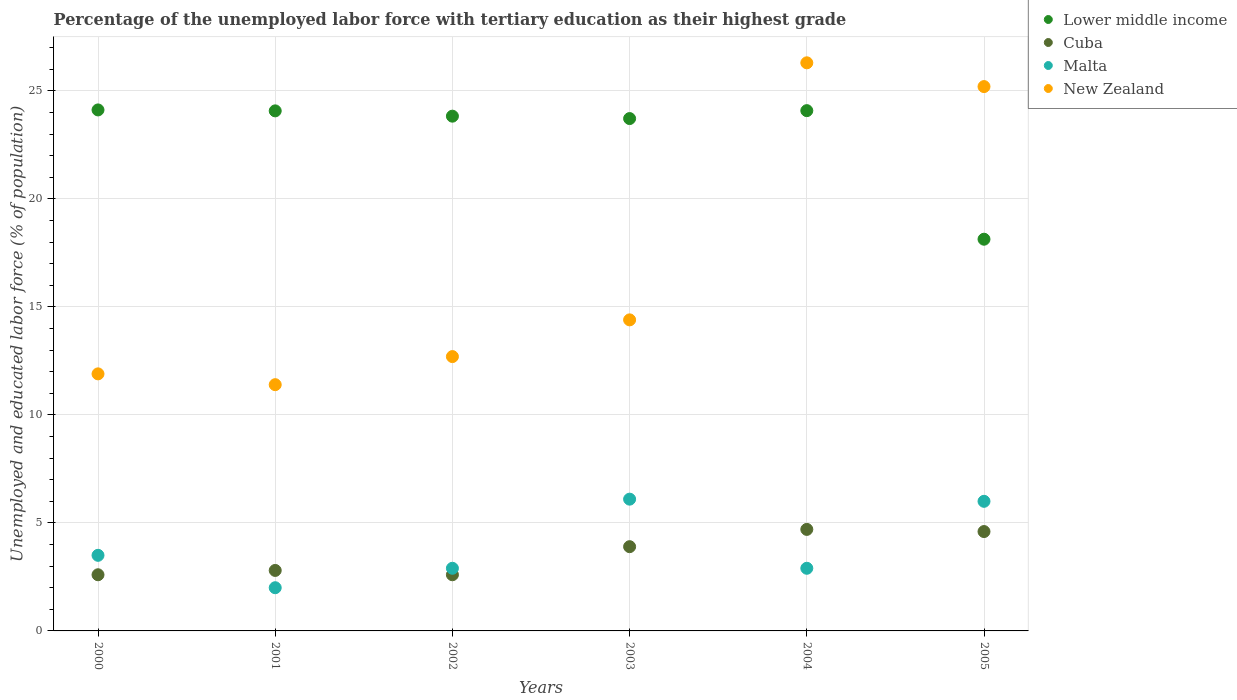What is the percentage of the unemployed labor force with tertiary education in Cuba in 2000?
Your answer should be very brief. 2.6. Across all years, what is the maximum percentage of the unemployed labor force with tertiary education in New Zealand?
Provide a short and direct response. 26.3. Across all years, what is the minimum percentage of the unemployed labor force with tertiary education in Cuba?
Your response must be concise. 2.6. In which year was the percentage of the unemployed labor force with tertiary education in Malta maximum?
Offer a very short reply. 2003. What is the total percentage of the unemployed labor force with tertiary education in Lower middle income in the graph?
Your answer should be compact. 137.96. What is the difference between the percentage of the unemployed labor force with tertiary education in Malta in 2003 and that in 2005?
Your answer should be very brief. 0.1. What is the difference between the percentage of the unemployed labor force with tertiary education in Cuba in 2003 and the percentage of the unemployed labor force with tertiary education in Malta in 2005?
Give a very brief answer. -2.1. What is the average percentage of the unemployed labor force with tertiary education in Malta per year?
Provide a short and direct response. 3.9. In the year 2002, what is the difference between the percentage of the unemployed labor force with tertiary education in Lower middle income and percentage of the unemployed labor force with tertiary education in Malta?
Offer a terse response. 20.93. In how many years, is the percentage of the unemployed labor force with tertiary education in Cuba greater than 24 %?
Offer a terse response. 0. What is the ratio of the percentage of the unemployed labor force with tertiary education in Lower middle income in 2001 to that in 2004?
Your response must be concise. 1. Is the percentage of the unemployed labor force with tertiary education in New Zealand in 2002 less than that in 2005?
Provide a succinct answer. Yes. Is the difference between the percentage of the unemployed labor force with tertiary education in Lower middle income in 2000 and 2005 greater than the difference between the percentage of the unemployed labor force with tertiary education in Malta in 2000 and 2005?
Offer a terse response. Yes. What is the difference between the highest and the second highest percentage of the unemployed labor force with tertiary education in New Zealand?
Make the answer very short. 1.1. What is the difference between the highest and the lowest percentage of the unemployed labor force with tertiary education in New Zealand?
Your response must be concise. 14.9. In how many years, is the percentage of the unemployed labor force with tertiary education in Malta greater than the average percentage of the unemployed labor force with tertiary education in Malta taken over all years?
Your answer should be compact. 2. Is the sum of the percentage of the unemployed labor force with tertiary education in Lower middle income in 2001 and 2005 greater than the maximum percentage of the unemployed labor force with tertiary education in Cuba across all years?
Make the answer very short. Yes. How many years are there in the graph?
Your answer should be very brief. 6. What is the difference between two consecutive major ticks on the Y-axis?
Offer a very short reply. 5. Where does the legend appear in the graph?
Make the answer very short. Top right. How many legend labels are there?
Provide a succinct answer. 4. How are the legend labels stacked?
Make the answer very short. Vertical. What is the title of the graph?
Your answer should be compact. Percentage of the unemployed labor force with tertiary education as their highest grade. What is the label or title of the Y-axis?
Provide a succinct answer. Unemployed and educated labor force (% of population). What is the Unemployed and educated labor force (% of population) of Lower middle income in 2000?
Offer a terse response. 24.12. What is the Unemployed and educated labor force (% of population) in Cuba in 2000?
Your answer should be compact. 2.6. What is the Unemployed and educated labor force (% of population) in New Zealand in 2000?
Offer a terse response. 11.9. What is the Unemployed and educated labor force (% of population) in Lower middle income in 2001?
Offer a very short reply. 24.08. What is the Unemployed and educated labor force (% of population) in Cuba in 2001?
Your answer should be very brief. 2.8. What is the Unemployed and educated labor force (% of population) of Malta in 2001?
Make the answer very short. 2. What is the Unemployed and educated labor force (% of population) of New Zealand in 2001?
Your response must be concise. 11.4. What is the Unemployed and educated labor force (% of population) in Lower middle income in 2002?
Ensure brevity in your answer.  23.83. What is the Unemployed and educated labor force (% of population) in Cuba in 2002?
Provide a succinct answer. 2.6. What is the Unemployed and educated labor force (% of population) in Malta in 2002?
Your answer should be compact. 2.9. What is the Unemployed and educated labor force (% of population) in New Zealand in 2002?
Offer a very short reply. 12.7. What is the Unemployed and educated labor force (% of population) of Lower middle income in 2003?
Provide a short and direct response. 23.72. What is the Unemployed and educated labor force (% of population) in Cuba in 2003?
Your response must be concise. 3.9. What is the Unemployed and educated labor force (% of population) in Malta in 2003?
Make the answer very short. 6.1. What is the Unemployed and educated labor force (% of population) in New Zealand in 2003?
Offer a very short reply. 14.4. What is the Unemployed and educated labor force (% of population) in Lower middle income in 2004?
Provide a short and direct response. 24.09. What is the Unemployed and educated labor force (% of population) of Cuba in 2004?
Ensure brevity in your answer.  4.7. What is the Unemployed and educated labor force (% of population) in Malta in 2004?
Your answer should be very brief. 2.9. What is the Unemployed and educated labor force (% of population) of New Zealand in 2004?
Make the answer very short. 26.3. What is the Unemployed and educated labor force (% of population) of Lower middle income in 2005?
Offer a terse response. 18.13. What is the Unemployed and educated labor force (% of population) in Cuba in 2005?
Ensure brevity in your answer.  4.6. What is the Unemployed and educated labor force (% of population) in Malta in 2005?
Your answer should be very brief. 6. What is the Unemployed and educated labor force (% of population) in New Zealand in 2005?
Provide a short and direct response. 25.2. Across all years, what is the maximum Unemployed and educated labor force (% of population) in Lower middle income?
Ensure brevity in your answer.  24.12. Across all years, what is the maximum Unemployed and educated labor force (% of population) of Cuba?
Your response must be concise. 4.7. Across all years, what is the maximum Unemployed and educated labor force (% of population) in Malta?
Your answer should be compact. 6.1. Across all years, what is the maximum Unemployed and educated labor force (% of population) in New Zealand?
Your response must be concise. 26.3. Across all years, what is the minimum Unemployed and educated labor force (% of population) of Lower middle income?
Offer a terse response. 18.13. Across all years, what is the minimum Unemployed and educated labor force (% of population) of Cuba?
Keep it short and to the point. 2.6. Across all years, what is the minimum Unemployed and educated labor force (% of population) of Malta?
Your answer should be compact. 2. Across all years, what is the minimum Unemployed and educated labor force (% of population) in New Zealand?
Your response must be concise. 11.4. What is the total Unemployed and educated labor force (% of population) in Lower middle income in the graph?
Your response must be concise. 137.96. What is the total Unemployed and educated labor force (% of population) of Cuba in the graph?
Offer a terse response. 21.2. What is the total Unemployed and educated labor force (% of population) of Malta in the graph?
Your answer should be compact. 23.4. What is the total Unemployed and educated labor force (% of population) of New Zealand in the graph?
Your response must be concise. 101.9. What is the difference between the Unemployed and educated labor force (% of population) in Lower middle income in 2000 and that in 2001?
Provide a succinct answer. 0.04. What is the difference between the Unemployed and educated labor force (% of population) in Cuba in 2000 and that in 2001?
Offer a terse response. -0.2. What is the difference between the Unemployed and educated labor force (% of population) in New Zealand in 2000 and that in 2001?
Your answer should be very brief. 0.5. What is the difference between the Unemployed and educated labor force (% of population) in Lower middle income in 2000 and that in 2002?
Your answer should be compact. 0.29. What is the difference between the Unemployed and educated labor force (% of population) in Cuba in 2000 and that in 2002?
Offer a terse response. 0. What is the difference between the Unemployed and educated labor force (% of population) in Lower middle income in 2000 and that in 2003?
Offer a terse response. 0.4. What is the difference between the Unemployed and educated labor force (% of population) of Cuba in 2000 and that in 2003?
Give a very brief answer. -1.3. What is the difference between the Unemployed and educated labor force (% of population) of Malta in 2000 and that in 2003?
Ensure brevity in your answer.  -2.6. What is the difference between the Unemployed and educated labor force (% of population) of New Zealand in 2000 and that in 2003?
Your answer should be very brief. -2.5. What is the difference between the Unemployed and educated labor force (% of population) in Lower middle income in 2000 and that in 2004?
Offer a very short reply. 0.03. What is the difference between the Unemployed and educated labor force (% of population) of New Zealand in 2000 and that in 2004?
Provide a succinct answer. -14.4. What is the difference between the Unemployed and educated labor force (% of population) in Lower middle income in 2000 and that in 2005?
Provide a succinct answer. 5.99. What is the difference between the Unemployed and educated labor force (% of population) in Cuba in 2000 and that in 2005?
Ensure brevity in your answer.  -2. What is the difference between the Unemployed and educated labor force (% of population) of Lower middle income in 2001 and that in 2002?
Make the answer very short. 0.25. What is the difference between the Unemployed and educated labor force (% of population) in Cuba in 2001 and that in 2002?
Offer a very short reply. 0.2. What is the difference between the Unemployed and educated labor force (% of population) in Lower middle income in 2001 and that in 2003?
Offer a terse response. 0.36. What is the difference between the Unemployed and educated labor force (% of population) of Malta in 2001 and that in 2003?
Provide a short and direct response. -4.1. What is the difference between the Unemployed and educated labor force (% of population) of Lower middle income in 2001 and that in 2004?
Keep it short and to the point. -0.01. What is the difference between the Unemployed and educated labor force (% of population) in Cuba in 2001 and that in 2004?
Ensure brevity in your answer.  -1.9. What is the difference between the Unemployed and educated labor force (% of population) of Malta in 2001 and that in 2004?
Ensure brevity in your answer.  -0.9. What is the difference between the Unemployed and educated labor force (% of population) of New Zealand in 2001 and that in 2004?
Offer a very short reply. -14.9. What is the difference between the Unemployed and educated labor force (% of population) in Lower middle income in 2001 and that in 2005?
Provide a short and direct response. 5.94. What is the difference between the Unemployed and educated labor force (% of population) of Cuba in 2001 and that in 2005?
Provide a succinct answer. -1.8. What is the difference between the Unemployed and educated labor force (% of population) of Malta in 2001 and that in 2005?
Make the answer very short. -4. What is the difference between the Unemployed and educated labor force (% of population) in Lower middle income in 2002 and that in 2003?
Provide a short and direct response. 0.11. What is the difference between the Unemployed and educated labor force (% of population) of Malta in 2002 and that in 2003?
Ensure brevity in your answer.  -3.2. What is the difference between the Unemployed and educated labor force (% of population) of New Zealand in 2002 and that in 2003?
Provide a succinct answer. -1.7. What is the difference between the Unemployed and educated labor force (% of population) of Lower middle income in 2002 and that in 2004?
Provide a succinct answer. -0.26. What is the difference between the Unemployed and educated labor force (% of population) in Cuba in 2002 and that in 2004?
Provide a succinct answer. -2.1. What is the difference between the Unemployed and educated labor force (% of population) in Lower middle income in 2002 and that in 2005?
Your answer should be very brief. 5.7. What is the difference between the Unemployed and educated labor force (% of population) in Cuba in 2002 and that in 2005?
Give a very brief answer. -2. What is the difference between the Unemployed and educated labor force (% of population) of New Zealand in 2002 and that in 2005?
Keep it short and to the point. -12.5. What is the difference between the Unemployed and educated labor force (% of population) of Lower middle income in 2003 and that in 2004?
Your response must be concise. -0.37. What is the difference between the Unemployed and educated labor force (% of population) of Lower middle income in 2003 and that in 2005?
Offer a terse response. 5.59. What is the difference between the Unemployed and educated labor force (% of population) in Lower middle income in 2004 and that in 2005?
Provide a short and direct response. 5.95. What is the difference between the Unemployed and educated labor force (% of population) in Malta in 2004 and that in 2005?
Provide a short and direct response. -3.1. What is the difference between the Unemployed and educated labor force (% of population) of Lower middle income in 2000 and the Unemployed and educated labor force (% of population) of Cuba in 2001?
Keep it short and to the point. 21.32. What is the difference between the Unemployed and educated labor force (% of population) in Lower middle income in 2000 and the Unemployed and educated labor force (% of population) in Malta in 2001?
Your response must be concise. 22.12. What is the difference between the Unemployed and educated labor force (% of population) in Lower middle income in 2000 and the Unemployed and educated labor force (% of population) in New Zealand in 2001?
Keep it short and to the point. 12.72. What is the difference between the Unemployed and educated labor force (% of population) in Cuba in 2000 and the Unemployed and educated labor force (% of population) in Malta in 2001?
Your answer should be very brief. 0.6. What is the difference between the Unemployed and educated labor force (% of population) in Lower middle income in 2000 and the Unemployed and educated labor force (% of population) in Cuba in 2002?
Offer a terse response. 21.52. What is the difference between the Unemployed and educated labor force (% of population) of Lower middle income in 2000 and the Unemployed and educated labor force (% of population) of Malta in 2002?
Give a very brief answer. 21.22. What is the difference between the Unemployed and educated labor force (% of population) in Lower middle income in 2000 and the Unemployed and educated labor force (% of population) in New Zealand in 2002?
Give a very brief answer. 11.42. What is the difference between the Unemployed and educated labor force (% of population) in Cuba in 2000 and the Unemployed and educated labor force (% of population) in New Zealand in 2002?
Your answer should be very brief. -10.1. What is the difference between the Unemployed and educated labor force (% of population) in Lower middle income in 2000 and the Unemployed and educated labor force (% of population) in Cuba in 2003?
Provide a short and direct response. 20.22. What is the difference between the Unemployed and educated labor force (% of population) in Lower middle income in 2000 and the Unemployed and educated labor force (% of population) in Malta in 2003?
Ensure brevity in your answer.  18.02. What is the difference between the Unemployed and educated labor force (% of population) of Lower middle income in 2000 and the Unemployed and educated labor force (% of population) of New Zealand in 2003?
Provide a succinct answer. 9.72. What is the difference between the Unemployed and educated labor force (% of population) in Lower middle income in 2000 and the Unemployed and educated labor force (% of population) in Cuba in 2004?
Keep it short and to the point. 19.42. What is the difference between the Unemployed and educated labor force (% of population) in Lower middle income in 2000 and the Unemployed and educated labor force (% of population) in Malta in 2004?
Your answer should be compact. 21.22. What is the difference between the Unemployed and educated labor force (% of population) in Lower middle income in 2000 and the Unemployed and educated labor force (% of population) in New Zealand in 2004?
Your response must be concise. -2.18. What is the difference between the Unemployed and educated labor force (% of population) of Cuba in 2000 and the Unemployed and educated labor force (% of population) of New Zealand in 2004?
Offer a terse response. -23.7. What is the difference between the Unemployed and educated labor force (% of population) in Malta in 2000 and the Unemployed and educated labor force (% of population) in New Zealand in 2004?
Your response must be concise. -22.8. What is the difference between the Unemployed and educated labor force (% of population) in Lower middle income in 2000 and the Unemployed and educated labor force (% of population) in Cuba in 2005?
Provide a succinct answer. 19.52. What is the difference between the Unemployed and educated labor force (% of population) of Lower middle income in 2000 and the Unemployed and educated labor force (% of population) of Malta in 2005?
Provide a short and direct response. 18.12. What is the difference between the Unemployed and educated labor force (% of population) in Lower middle income in 2000 and the Unemployed and educated labor force (% of population) in New Zealand in 2005?
Ensure brevity in your answer.  -1.08. What is the difference between the Unemployed and educated labor force (% of population) of Cuba in 2000 and the Unemployed and educated labor force (% of population) of New Zealand in 2005?
Ensure brevity in your answer.  -22.6. What is the difference between the Unemployed and educated labor force (% of population) of Malta in 2000 and the Unemployed and educated labor force (% of population) of New Zealand in 2005?
Your answer should be very brief. -21.7. What is the difference between the Unemployed and educated labor force (% of population) in Lower middle income in 2001 and the Unemployed and educated labor force (% of population) in Cuba in 2002?
Offer a terse response. 21.48. What is the difference between the Unemployed and educated labor force (% of population) in Lower middle income in 2001 and the Unemployed and educated labor force (% of population) in Malta in 2002?
Keep it short and to the point. 21.18. What is the difference between the Unemployed and educated labor force (% of population) of Lower middle income in 2001 and the Unemployed and educated labor force (% of population) of New Zealand in 2002?
Offer a very short reply. 11.38. What is the difference between the Unemployed and educated labor force (% of population) of Cuba in 2001 and the Unemployed and educated labor force (% of population) of Malta in 2002?
Your answer should be very brief. -0.1. What is the difference between the Unemployed and educated labor force (% of population) of Cuba in 2001 and the Unemployed and educated labor force (% of population) of New Zealand in 2002?
Make the answer very short. -9.9. What is the difference between the Unemployed and educated labor force (% of population) in Malta in 2001 and the Unemployed and educated labor force (% of population) in New Zealand in 2002?
Your response must be concise. -10.7. What is the difference between the Unemployed and educated labor force (% of population) of Lower middle income in 2001 and the Unemployed and educated labor force (% of population) of Cuba in 2003?
Make the answer very short. 20.18. What is the difference between the Unemployed and educated labor force (% of population) of Lower middle income in 2001 and the Unemployed and educated labor force (% of population) of Malta in 2003?
Provide a short and direct response. 17.98. What is the difference between the Unemployed and educated labor force (% of population) in Lower middle income in 2001 and the Unemployed and educated labor force (% of population) in New Zealand in 2003?
Ensure brevity in your answer.  9.68. What is the difference between the Unemployed and educated labor force (% of population) of Cuba in 2001 and the Unemployed and educated labor force (% of population) of Malta in 2003?
Your answer should be compact. -3.3. What is the difference between the Unemployed and educated labor force (% of population) in Malta in 2001 and the Unemployed and educated labor force (% of population) in New Zealand in 2003?
Offer a very short reply. -12.4. What is the difference between the Unemployed and educated labor force (% of population) in Lower middle income in 2001 and the Unemployed and educated labor force (% of population) in Cuba in 2004?
Give a very brief answer. 19.38. What is the difference between the Unemployed and educated labor force (% of population) in Lower middle income in 2001 and the Unemployed and educated labor force (% of population) in Malta in 2004?
Your answer should be very brief. 21.18. What is the difference between the Unemployed and educated labor force (% of population) of Lower middle income in 2001 and the Unemployed and educated labor force (% of population) of New Zealand in 2004?
Provide a short and direct response. -2.22. What is the difference between the Unemployed and educated labor force (% of population) in Cuba in 2001 and the Unemployed and educated labor force (% of population) in Malta in 2004?
Offer a very short reply. -0.1. What is the difference between the Unemployed and educated labor force (% of population) of Cuba in 2001 and the Unemployed and educated labor force (% of population) of New Zealand in 2004?
Offer a very short reply. -23.5. What is the difference between the Unemployed and educated labor force (% of population) in Malta in 2001 and the Unemployed and educated labor force (% of population) in New Zealand in 2004?
Your response must be concise. -24.3. What is the difference between the Unemployed and educated labor force (% of population) in Lower middle income in 2001 and the Unemployed and educated labor force (% of population) in Cuba in 2005?
Your answer should be compact. 19.48. What is the difference between the Unemployed and educated labor force (% of population) of Lower middle income in 2001 and the Unemployed and educated labor force (% of population) of Malta in 2005?
Give a very brief answer. 18.08. What is the difference between the Unemployed and educated labor force (% of population) in Lower middle income in 2001 and the Unemployed and educated labor force (% of population) in New Zealand in 2005?
Your response must be concise. -1.12. What is the difference between the Unemployed and educated labor force (% of population) of Cuba in 2001 and the Unemployed and educated labor force (% of population) of New Zealand in 2005?
Offer a very short reply. -22.4. What is the difference between the Unemployed and educated labor force (% of population) in Malta in 2001 and the Unemployed and educated labor force (% of population) in New Zealand in 2005?
Give a very brief answer. -23.2. What is the difference between the Unemployed and educated labor force (% of population) of Lower middle income in 2002 and the Unemployed and educated labor force (% of population) of Cuba in 2003?
Your answer should be compact. 19.93. What is the difference between the Unemployed and educated labor force (% of population) of Lower middle income in 2002 and the Unemployed and educated labor force (% of population) of Malta in 2003?
Your answer should be very brief. 17.73. What is the difference between the Unemployed and educated labor force (% of population) of Lower middle income in 2002 and the Unemployed and educated labor force (% of population) of New Zealand in 2003?
Provide a short and direct response. 9.43. What is the difference between the Unemployed and educated labor force (% of population) of Lower middle income in 2002 and the Unemployed and educated labor force (% of population) of Cuba in 2004?
Provide a short and direct response. 19.13. What is the difference between the Unemployed and educated labor force (% of population) of Lower middle income in 2002 and the Unemployed and educated labor force (% of population) of Malta in 2004?
Your response must be concise. 20.93. What is the difference between the Unemployed and educated labor force (% of population) of Lower middle income in 2002 and the Unemployed and educated labor force (% of population) of New Zealand in 2004?
Provide a short and direct response. -2.47. What is the difference between the Unemployed and educated labor force (% of population) in Cuba in 2002 and the Unemployed and educated labor force (% of population) in Malta in 2004?
Your answer should be very brief. -0.3. What is the difference between the Unemployed and educated labor force (% of population) of Cuba in 2002 and the Unemployed and educated labor force (% of population) of New Zealand in 2004?
Ensure brevity in your answer.  -23.7. What is the difference between the Unemployed and educated labor force (% of population) in Malta in 2002 and the Unemployed and educated labor force (% of population) in New Zealand in 2004?
Provide a succinct answer. -23.4. What is the difference between the Unemployed and educated labor force (% of population) in Lower middle income in 2002 and the Unemployed and educated labor force (% of population) in Cuba in 2005?
Your response must be concise. 19.23. What is the difference between the Unemployed and educated labor force (% of population) in Lower middle income in 2002 and the Unemployed and educated labor force (% of population) in Malta in 2005?
Offer a terse response. 17.83. What is the difference between the Unemployed and educated labor force (% of population) in Lower middle income in 2002 and the Unemployed and educated labor force (% of population) in New Zealand in 2005?
Ensure brevity in your answer.  -1.37. What is the difference between the Unemployed and educated labor force (% of population) in Cuba in 2002 and the Unemployed and educated labor force (% of population) in New Zealand in 2005?
Offer a very short reply. -22.6. What is the difference between the Unemployed and educated labor force (% of population) of Malta in 2002 and the Unemployed and educated labor force (% of population) of New Zealand in 2005?
Make the answer very short. -22.3. What is the difference between the Unemployed and educated labor force (% of population) of Lower middle income in 2003 and the Unemployed and educated labor force (% of population) of Cuba in 2004?
Give a very brief answer. 19.02. What is the difference between the Unemployed and educated labor force (% of population) in Lower middle income in 2003 and the Unemployed and educated labor force (% of population) in Malta in 2004?
Offer a terse response. 20.82. What is the difference between the Unemployed and educated labor force (% of population) in Lower middle income in 2003 and the Unemployed and educated labor force (% of population) in New Zealand in 2004?
Offer a terse response. -2.58. What is the difference between the Unemployed and educated labor force (% of population) in Cuba in 2003 and the Unemployed and educated labor force (% of population) in Malta in 2004?
Offer a very short reply. 1. What is the difference between the Unemployed and educated labor force (% of population) of Cuba in 2003 and the Unemployed and educated labor force (% of population) of New Zealand in 2004?
Your response must be concise. -22.4. What is the difference between the Unemployed and educated labor force (% of population) of Malta in 2003 and the Unemployed and educated labor force (% of population) of New Zealand in 2004?
Ensure brevity in your answer.  -20.2. What is the difference between the Unemployed and educated labor force (% of population) of Lower middle income in 2003 and the Unemployed and educated labor force (% of population) of Cuba in 2005?
Keep it short and to the point. 19.12. What is the difference between the Unemployed and educated labor force (% of population) of Lower middle income in 2003 and the Unemployed and educated labor force (% of population) of Malta in 2005?
Offer a terse response. 17.72. What is the difference between the Unemployed and educated labor force (% of population) of Lower middle income in 2003 and the Unemployed and educated labor force (% of population) of New Zealand in 2005?
Keep it short and to the point. -1.48. What is the difference between the Unemployed and educated labor force (% of population) of Cuba in 2003 and the Unemployed and educated labor force (% of population) of New Zealand in 2005?
Your response must be concise. -21.3. What is the difference between the Unemployed and educated labor force (% of population) of Malta in 2003 and the Unemployed and educated labor force (% of population) of New Zealand in 2005?
Give a very brief answer. -19.1. What is the difference between the Unemployed and educated labor force (% of population) of Lower middle income in 2004 and the Unemployed and educated labor force (% of population) of Cuba in 2005?
Offer a very short reply. 19.49. What is the difference between the Unemployed and educated labor force (% of population) in Lower middle income in 2004 and the Unemployed and educated labor force (% of population) in Malta in 2005?
Your answer should be very brief. 18.09. What is the difference between the Unemployed and educated labor force (% of population) of Lower middle income in 2004 and the Unemployed and educated labor force (% of population) of New Zealand in 2005?
Provide a short and direct response. -1.11. What is the difference between the Unemployed and educated labor force (% of population) in Cuba in 2004 and the Unemployed and educated labor force (% of population) in Malta in 2005?
Offer a very short reply. -1.3. What is the difference between the Unemployed and educated labor force (% of population) in Cuba in 2004 and the Unemployed and educated labor force (% of population) in New Zealand in 2005?
Provide a succinct answer. -20.5. What is the difference between the Unemployed and educated labor force (% of population) of Malta in 2004 and the Unemployed and educated labor force (% of population) of New Zealand in 2005?
Your answer should be very brief. -22.3. What is the average Unemployed and educated labor force (% of population) in Lower middle income per year?
Your response must be concise. 22.99. What is the average Unemployed and educated labor force (% of population) in Cuba per year?
Your answer should be compact. 3.53. What is the average Unemployed and educated labor force (% of population) in New Zealand per year?
Ensure brevity in your answer.  16.98. In the year 2000, what is the difference between the Unemployed and educated labor force (% of population) in Lower middle income and Unemployed and educated labor force (% of population) in Cuba?
Provide a succinct answer. 21.52. In the year 2000, what is the difference between the Unemployed and educated labor force (% of population) of Lower middle income and Unemployed and educated labor force (% of population) of Malta?
Provide a short and direct response. 20.62. In the year 2000, what is the difference between the Unemployed and educated labor force (% of population) in Lower middle income and Unemployed and educated labor force (% of population) in New Zealand?
Your answer should be very brief. 12.22. In the year 2000, what is the difference between the Unemployed and educated labor force (% of population) of Cuba and Unemployed and educated labor force (% of population) of New Zealand?
Provide a succinct answer. -9.3. In the year 2000, what is the difference between the Unemployed and educated labor force (% of population) of Malta and Unemployed and educated labor force (% of population) of New Zealand?
Your answer should be very brief. -8.4. In the year 2001, what is the difference between the Unemployed and educated labor force (% of population) in Lower middle income and Unemployed and educated labor force (% of population) in Cuba?
Ensure brevity in your answer.  21.28. In the year 2001, what is the difference between the Unemployed and educated labor force (% of population) in Lower middle income and Unemployed and educated labor force (% of population) in Malta?
Give a very brief answer. 22.08. In the year 2001, what is the difference between the Unemployed and educated labor force (% of population) in Lower middle income and Unemployed and educated labor force (% of population) in New Zealand?
Your answer should be very brief. 12.68. In the year 2001, what is the difference between the Unemployed and educated labor force (% of population) of Cuba and Unemployed and educated labor force (% of population) of Malta?
Offer a very short reply. 0.8. In the year 2001, what is the difference between the Unemployed and educated labor force (% of population) of Malta and Unemployed and educated labor force (% of population) of New Zealand?
Keep it short and to the point. -9.4. In the year 2002, what is the difference between the Unemployed and educated labor force (% of population) of Lower middle income and Unemployed and educated labor force (% of population) of Cuba?
Your response must be concise. 21.23. In the year 2002, what is the difference between the Unemployed and educated labor force (% of population) in Lower middle income and Unemployed and educated labor force (% of population) in Malta?
Make the answer very short. 20.93. In the year 2002, what is the difference between the Unemployed and educated labor force (% of population) in Lower middle income and Unemployed and educated labor force (% of population) in New Zealand?
Ensure brevity in your answer.  11.13. In the year 2002, what is the difference between the Unemployed and educated labor force (% of population) of Malta and Unemployed and educated labor force (% of population) of New Zealand?
Make the answer very short. -9.8. In the year 2003, what is the difference between the Unemployed and educated labor force (% of population) in Lower middle income and Unemployed and educated labor force (% of population) in Cuba?
Your answer should be very brief. 19.82. In the year 2003, what is the difference between the Unemployed and educated labor force (% of population) in Lower middle income and Unemployed and educated labor force (% of population) in Malta?
Your answer should be very brief. 17.62. In the year 2003, what is the difference between the Unemployed and educated labor force (% of population) in Lower middle income and Unemployed and educated labor force (% of population) in New Zealand?
Make the answer very short. 9.32. In the year 2003, what is the difference between the Unemployed and educated labor force (% of population) in Cuba and Unemployed and educated labor force (% of population) in Malta?
Provide a short and direct response. -2.2. In the year 2004, what is the difference between the Unemployed and educated labor force (% of population) of Lower middle income and Unemployed and educated labor force (% of population) of Cuba?
Offer a terse response. 19.39. In the year 2004, what is the difference between the Unemployed and educated labor force (% of population) in Lower middle income and Unemployed and educated labor force (% of population) in Malta?
Your answer should be very brief. 21.19. In the year 2004, what is the difference between the Unemployed and educated labor force (% of population) of Lower middle income and Unemployed and educated labor force (% of population) of New Zealand?
Make the answer very short. -2.21. In the year 2004, what is the difference between the Unemployed and educated labor force (% of population) of Cuba and Unemployed and educated labor force (% of population) of New Zealand?
Keep it short and to the point. -21.6. In the year 2004, what is the difference between the Unemployed and educated labor force (% of population) in Malta and Unemployed and educated labor force (% of population) in New Zealand?
Give a very brief answer. -23.4. In the year 2005, what is the difference between the Unemployed and educated labor force (% of population) of Lower middle income and Unemployed and educated labor force (% of population) of Cuba?
Make the answer very short. 13.53. In the year 2005, what is the difference between the Unemployed and educated labor force (% of population) in Lower middle income and Unemployed and educated labor force (% of population) in Malta?
Keep it short and to the point. 12.13. In the year 2005, what is the difference between the Unemployed and educated labor force (% of population) in Lower middle income and Unemployed and educated labor force (% of population) in New Zealand?
Offer a terse response. -7.07. In the year 2005, what is the difference between the Unemployed and educated labor force (% of population) of Cuba and Unemployed and educated labor force (% of population) of Malta?
Your response must be concise. -1.4. In the year 2005, what is the difference between the Unemployed and educated labor force (% of population) of Cuba and Unemployed and educated labor force (% of population) of New Zealand?
Offer a terse response. -20.6. In the year 2005, what is the difference between the Unemployed and educated labor force (% of population) of Malta and Unemployed and educated labor force (% of population) of New Zealand?
Keep it short and to the point. -19.2. What is the ratio of the Unemployed and educated labor force (% of population) in Cuba in 2000 to that in 2001?
Your response must be concise. 0.93. What is the ratio of the Unemployed and educated labor force (% of population) in New Zealand in 2000 to that in 2001?
Provide a succinct answer. 1.04. What is the ratio of the Unemployed and educated labor force (% of population) of Lower middle income in 2000 to that in 2002?
Your answer should be compact. 1.01. What is the ratio of the Unemployed and educated labor force (% of population) in Malta in 2000 to that in 2002?
Ensure brevity in your answer.  1.21. What is the ratio of the Unemployed and educated labor force (% of population) of New Zealand in 2000 to that in 2002?
Provide a short and direct response. 0.94. What is the ratio of the Unemployed and educated labor force (% of population) in Lower middle income in 2000 to that in 2003?
Provide a short and direct response. 1.02. What is the ratio of the Unemployed and educated labor force (% of population) of Malta in 2000 to that in 2003?
Make the answer very short. 0.57. What is the ratio of the Unemployed and educated labor force (% of population) in New Zealand in 2000 to that in 2003?
Ensure brevity in your answer.  0.83. What is the ratio of the Unemployed and educated labor force (% of population) in Lower middle income in 2000 to that in 2004?
Make the answer very short. 1. What is the ratio of the Unemployed and educated labor force (% of population) of Cuba in 2000 to that in 2004?
Provide a short and direct response. 0.55. What is the ratio of the Unemployed and educated labor force (% of population) in Malta in 2000 to that in 2004?
Provide a short and direct response. 1.21. What is the ratio of the Unemployed and educated labor force (% of population) in New Zealand in 2000 to that in 2004?
Give a very brief answer. 0.45. What is the ratio of the Unemployed and educated labor force (% of population) in Lower middle income in 2000 to that in 2005?
Keep it short and to the point. 1.33. What is the ratio of the Unemployed and educated labor force (% of population) of Cuba in 2000 to that in 2005?
Offer a very short reply. 0.57. What is the ratio of the Unemployed and educated labor force (% of population) of Malta in 2000 to that in 2005?
Provide a short and direct response. 0.58. What is the ratio of the Unemployed and educated labor force (% of population) of New Zealand in 2000 to that in 2005?
Offer a very short reply. 0.47. What is the ratio of the Unemployed and educated labor force (% of population) of Lower middle income in 2001 to that in 2002?
Offer a very short reply. 1.01. What is the ratio of the Unemployed and educated labor force (% of population) of Malta in 2001 to that in 2002?
Make the answer very short. 0.69. What is the ratio of the Unemployed and educated labor force (% of population) in New Zealand in 2001 to that in 2002?
Offer a terse response. 0.9. What is the ratio of the Unemployed and educated labor force (% of population) in Lower middle income in 2001 to that in 2003?
Give a very brief answer. 1.01. What is the ratio of the Unemployed and educated labor force (% of population) of Cuba in 2001 to that in 2003?
Offer a terse response. 0.72. What is the ratio of the Unemployed and educated labor force (% of population) in Malta in 2001 to that in 2003?
Your answer should be compact. 0.33. What is the ratio of the Unemployed and educated labor force (% of population) of New Zealand in 2001 to that in 2003?
Ensure brevity in your answer.  0.79. What is the ratio of the Unemployed and educated labor force (% of population) of Lower middle income in 2001 to that in 2004?
Ensure brevity in your answer.  1. What is the ratio of the Unemployed and educated labor force (% of population) of Cuba in 2001 to that in 2004?
Your response must be concise. 0.6. What is the ratio of the Unemployed and educated labor force (% of population) in Malta in 2001 to that in 2004?
Your response must be concise. 0.69. What is the ratio of the Unemployed and educated labor force (% of population) of New Zealand in 2001 to that in 2004?
Your answer should be very brief. 0.43. What is the ratio of the Unemployed and educated labor force (% of population) of Lower middle income in 2001 to that in 2005?
Make the answer very short. 1.33. What is the ratio of the Unemployed and educated labor force (% of population) of Cuba in 2001 to that in 2005?
Ensure brevity in your answer.  0.61. What is the ratio of the Unemployed and educated labor force (% of population) in Malta in 2001 to that in 2005?
Offer a terse response. 0.33. What is the ratio of the Unemployed and educated labor force (% of population) in New Zealand in 2001 to that in 2005?
Your response must be concise. 0.45. What is the ratio of the Unemployed and educated labor force (% of population) in Lower middle income in 2002 to that in 2003?
Keep it short and to the point. 1. What is the ratio of the Unemployed and educated labor force (% of population) in Cuba in 2002 to that in 2003?
Offer a terse response. 0.67. What is the ratio of the Unemployed and educated labor force (% of population) in Malta in 2002 to that in 2003?
Offer a terse response. 0.48. What is the ratio of the Unemployed and educated labor force (% of population) of New Zealand in 2002 to that in 2003?
Offer a very short reply. 0.88. What is the ratio of the Unemployed and educated labor force (% of population) of Cuba in 2002 to that in 2004?
Provide a succinct answer. 0.55. What is the ratio of the Unemployed and educated labor force (% of population) in Malta in 2002 to that in 2004?
Make the answer very short. 1. What is the ratio of the Unemployed and educated labor force (% of population) in New Zealand in 2002 to that in 2004?
Provide a succinct answer. 0.48. What is the ratio of the Unemployed and educated labor force (% of population) in Lower middle income in 2002 to that in 2005?
Provide a succinct answer. 1.31. What is the ratio of the Unemployed and educated labor force (% of population) in Cuba in 2002 to that in 2005?
Your response must be concise. 0.57. What is the ratio of the Unemployed and educated labor force (% of population) of Malta in 2002 to that in 2005?
Provide a succinct answer. 0.48. What is the ratio of the Unemployed and educated labor force (% of population) in New Zealand in 2002 to that in 2005?
Provide a short and direct response. 0.5. What is the ratio of the Unemployed and educated labor force (% of population) in Lower middle income in 2003 to that in 2004?
Your answer should be very brief. 0.98. What is the ratio of the Unemployed and educated labor force (% of population) of Cuba in 2003 to that in 2004?
Provide a succinct answer. 0.83. What is the ratio of the Unemployed and educated labor force (% of population) in Malta in 2003 to that in 2004?
Your answer should be very brief. 2.1. What is the ratio of the Unemployed and educated labor force (% of population) of New Zealand in 2003 to that in 2004?
Give a very brief answer. 0.55. What is the ratio of the Unemployed and educated labor force (% of population) in Lower middle income in 2003 to that in 2005?
Make the answer very short. 1.31. What is the ratio of the Unemployed and educated labor force (% of population) in Cuba in 2003 to that in 2005?
Your answer should be very brief. 0.85. What is the ratio of the Unemployed and educated labor force (% of population) of Malta in 2003 to that in 2005?
Give a very brief answer. 1.02. What is the ratio of the Unemployed and educated labor force (% of population) of New Zealand in 2003 to that in 2005?
Your answer should be very brief. 0.57. What is the ratio of the Unemployed and educated labor force (% of population) in Lower middle income in 2004 to that in 2005?
Offer a very short reply. 1.33. What is the ratio of the Unemployed and educated labor force (% of population) in Cuba in 2004 to that in 2005?
Your response must be concise. 1.02. What is the ratio of the Unemployed and educated labor force (% of population) of Malta in 2004 to that in 2005?
Offer a terse response. 0.48. What is the ratio of the Unemployed and educated labor force (% of population) of New Zealand in 2004 to that in 2005?
Provide a short and direct response. 1.04. What is the difference between the highest and the second highest Unemployed and educated labor force (% of population) of Lower middle income?
Make the answer very short. 0.03. What is the difference between the highest and the lowest Unemployed and educated labor force (% of population) of Lower middle income?
Ensure brevity in your answer.  5.99. 